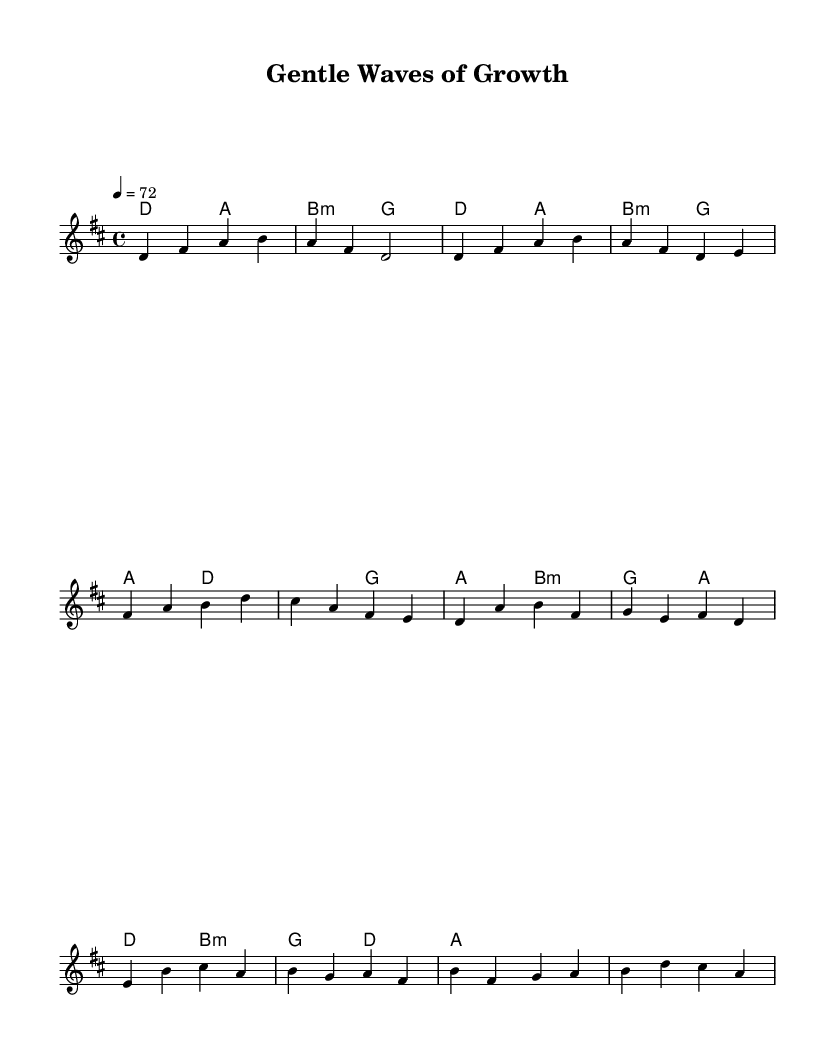What is the key signature of this music? The key signature is D major, which has two sharps: F sharp and C sharp. This can be identified by looking at the key signature shown at the beginning of the staff.
Answer: D major What is the time signature of the piece? The time signature is 4/4, as indicated at the beginning of the score. This means there are four beats in each measure, and the quarter note gets one beat.
Answer: 4/4 What is the tempo marking for the piece? The tempo marking is 72 beats per minute, indicated at the beginning of the score with the instruction "4 = 72". This suggests a moderate pace for the music.
Answer: 72 How many measures are in the chorus section? The chorus section consists of four measures, identifiable by the bracketed sections in the sheet music, which total to four unique groupings of beats.
Answer: Four measures What type of chords are primarily used in the introduction? The introduction primarily uses major chords, specifically D major and B minor. These chords are indicated in the harmonies section for the introduction part.
Answer: Major chords Which section of the music has an incomplete phrase? The bridge section is identified as having a partial or incomplete phrase, as it only contains two measures instead of completing a typical musical phrase format.
Answer: Bridge 